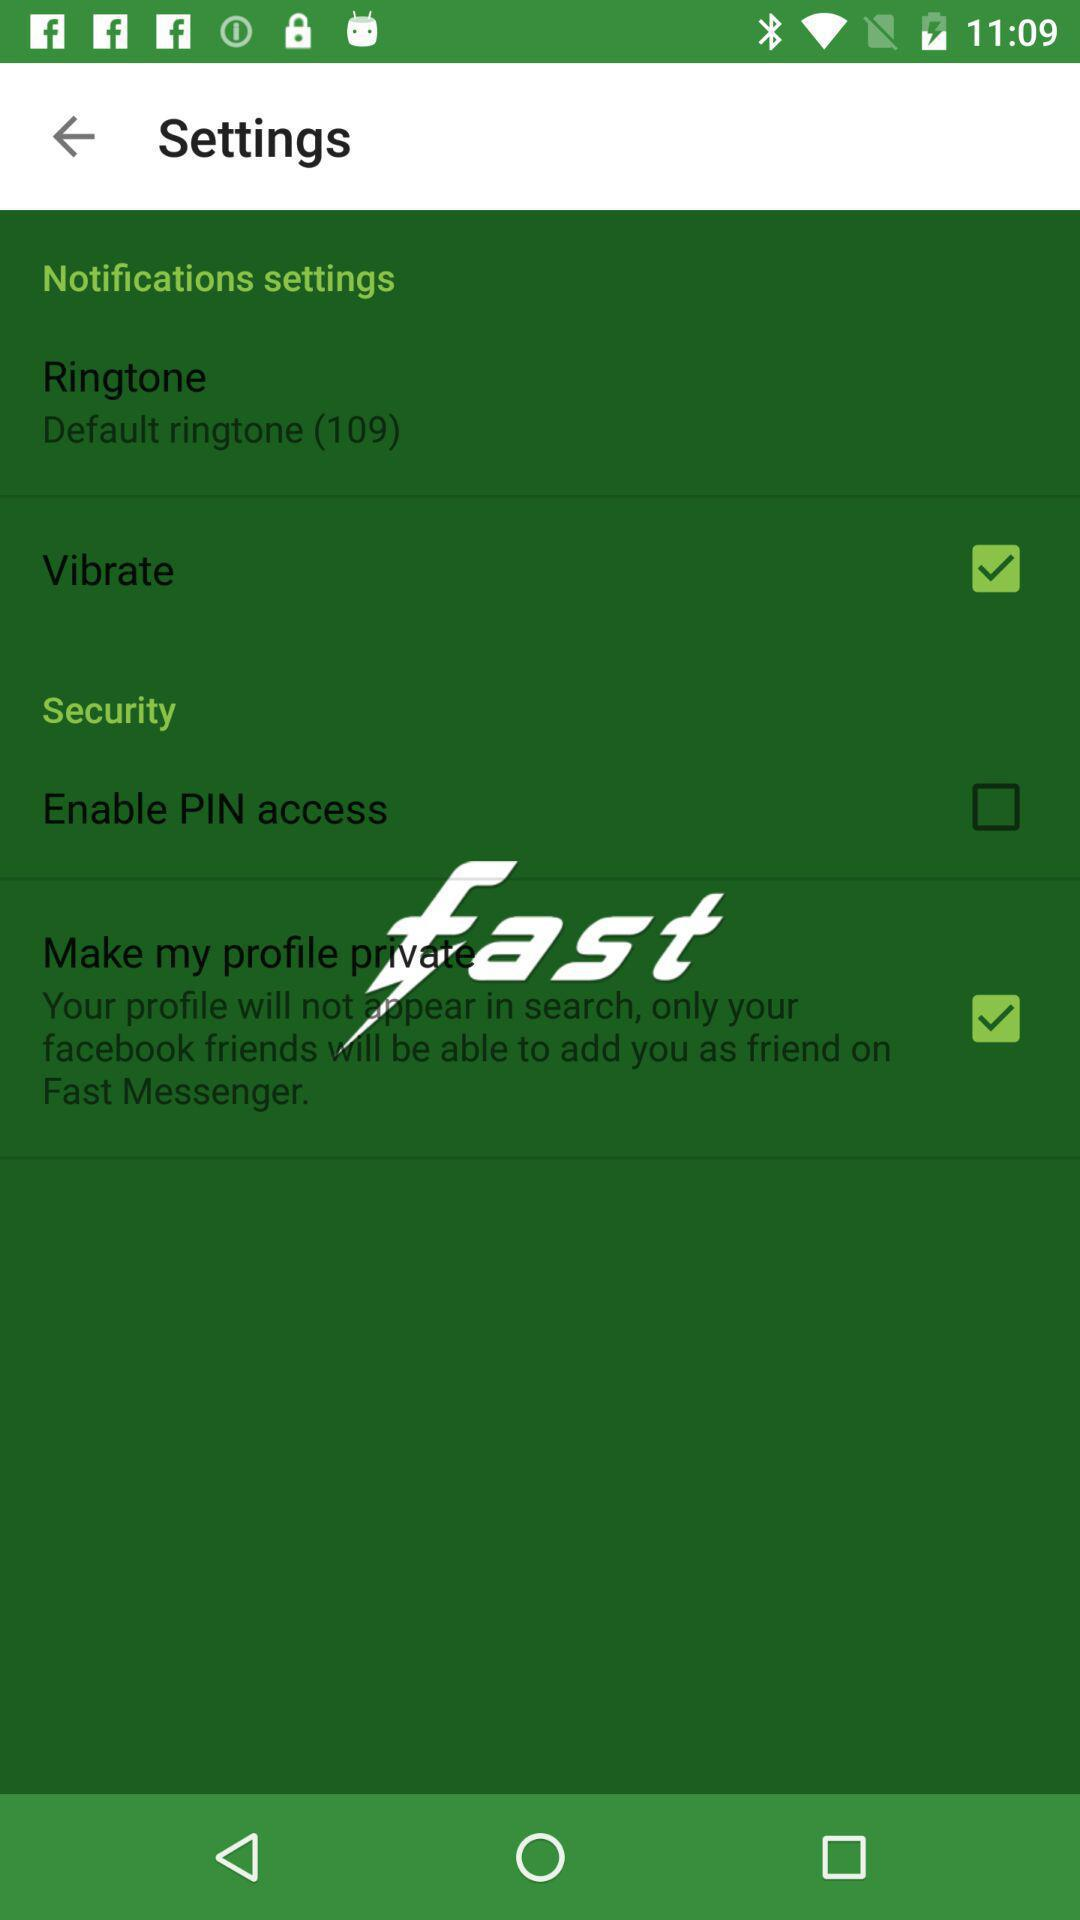What ringtone is shown on the screen? The ringtone shown on the screen is "Default ringtone (109)". 